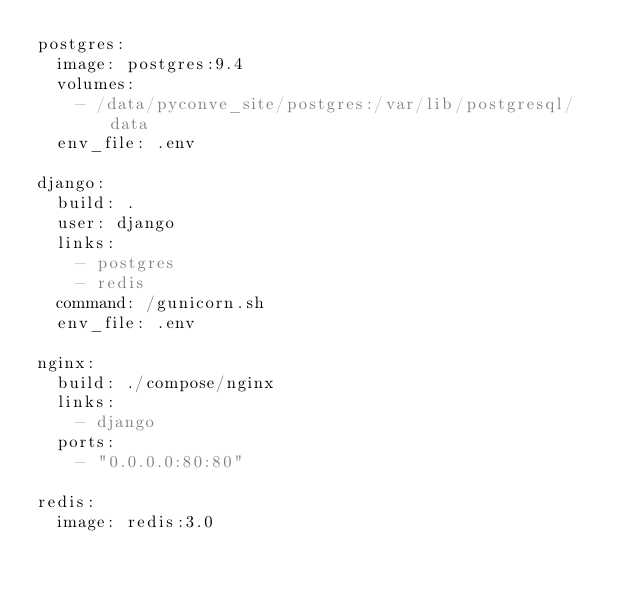<code> <loc_0><loc_0><loc_500><loc_500><_YAML_>postgres:
  image: postgres:9.4
  volumes:
    - /data/pyconve_site/postgres:/var/lib/postgresql/data
  env_file: .env

django:
  build: .
  user: django
  links:
    - postgres
    - redis
  command: /gunicorn.sh
  env_file: .env

nginx:
  build: ./compose/nginx
  links:
    - django
  ports:
    - "0.0.0.0:80:80"

redis:
  image: redis:3.0
</code> 